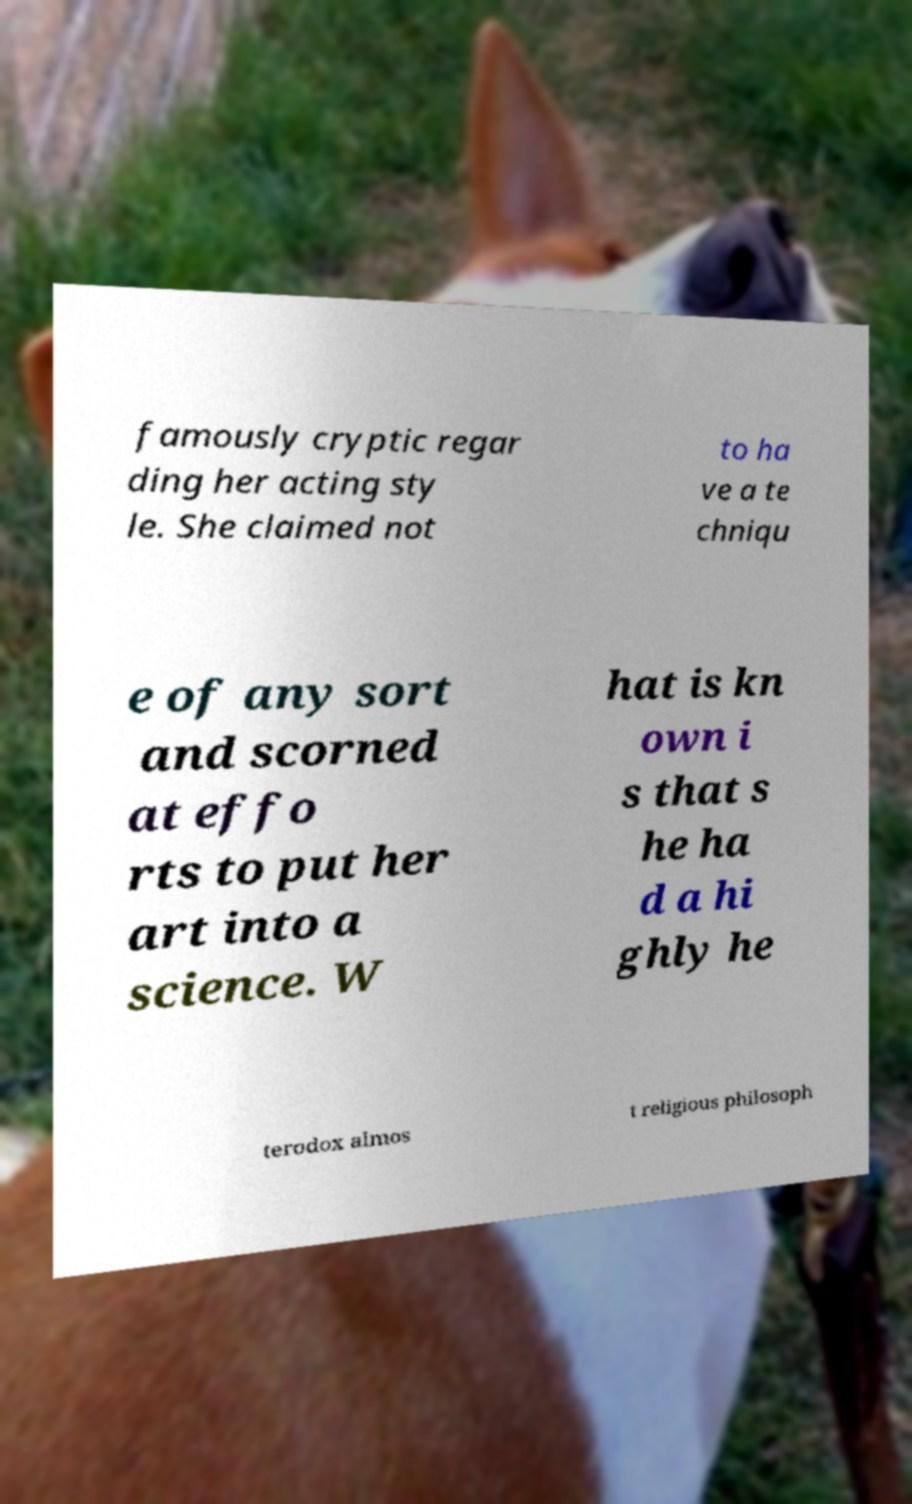I need the written content from this picture converted into text. Can you do that? famously cryptic regar ding her acting sty le. She claimed not to ha ve a te chniqu e of any sort and scorned at effo rts to put her art into a science. W hat is kn own i s that s he ha d a hi ghly he terodox almos t religious philosoph 